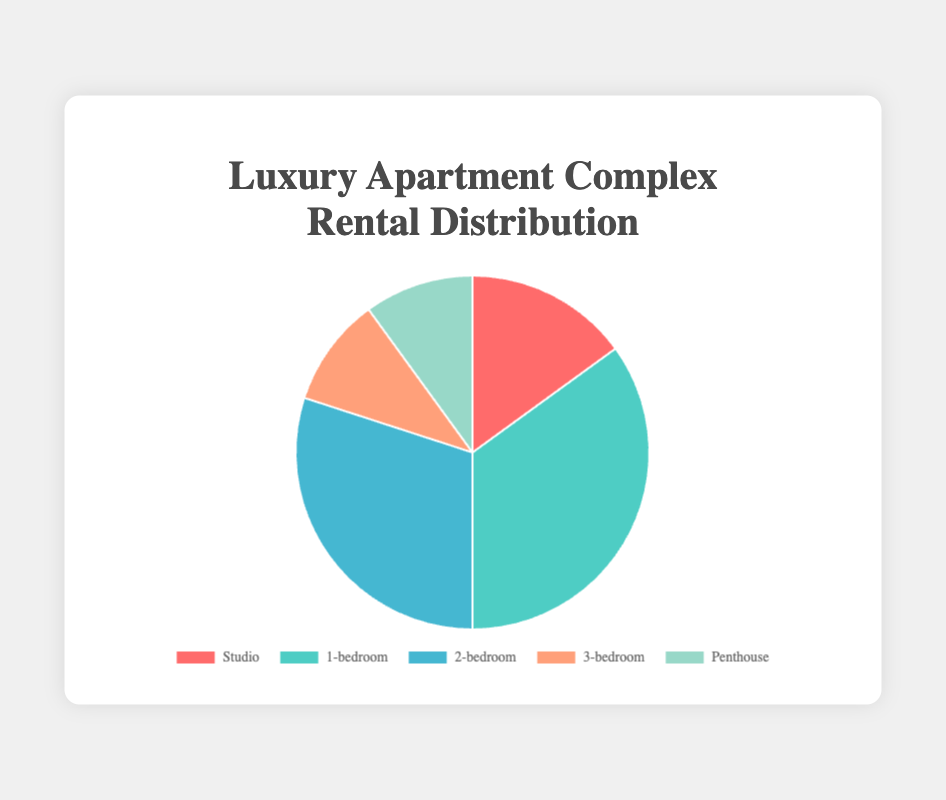What type of apartment is most commonly rented? By observing the figure, the type with the largest segment represents the most commonly rented apartment. The 1-bedroom apartment segment is significantly larger than the others.
Answer: 1-bedroom Which types of apartments have the lowest rental percentages? Looking at the smallest segments, we see that the 3-bedroom and Penthouse apartments share equally small segments of the pie chart.
Answer: 3-bedroom and Penthouse What is the total percentage of apartments rented that have more than one bedroom? Add together the percentage values for the 2-bedroom, 3-bedroom, and Penthouse apartments. The sum of 30% (2-bedroom), 10% (3-bedroom), and 10% (Penthouse) equals 50%.
Answer: 50% How much more prevalent are 1-bedroom rentals compared to 3-bedroom rentals? The 1-bedroom apartments have a percentage of 35%, and the 3-bedroom apartments have 10%. The difference between these values is 35% - 10% = 25%.
Answer: 25% What is the combined percentage of Studio and Penthouse apartments rented? Adding the percentages of Studio apartments (15%) and Penthouse apartments (10%) gives 15% + 10% = 25%.
Answer: 25% Which apartment type makes up one-fifth of the rentals? One-fifth of the rentals translates to 20%. None of the given types match this percentage exactly. The closest to 20% is Studio with 15%, but it doesn't equal 20%.
Answer: None Compare the rental percentages for Studio and 2-bedroom apartments. Which one is higher and by how much? The percentage for Studio apartments is 15%, and for 2-bedroom apartments, it’s 30%. The difference is 30% - 15% = 15%.
Answer: 2-bedroom by 15% What is the median rental percentage? First, list the percentages in ascending order: 10% (3-bedroom and Penthouse), 15% (Studio), 30% (2-bedroom), and 35% (1-bedroom). The median is the middle value. With an odd number like 5, the middle value is the third one, which is 30%.
Answer: 30% 